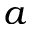<formula> <loc_0><loc_0><loc_500><loc_500>a</formula> 